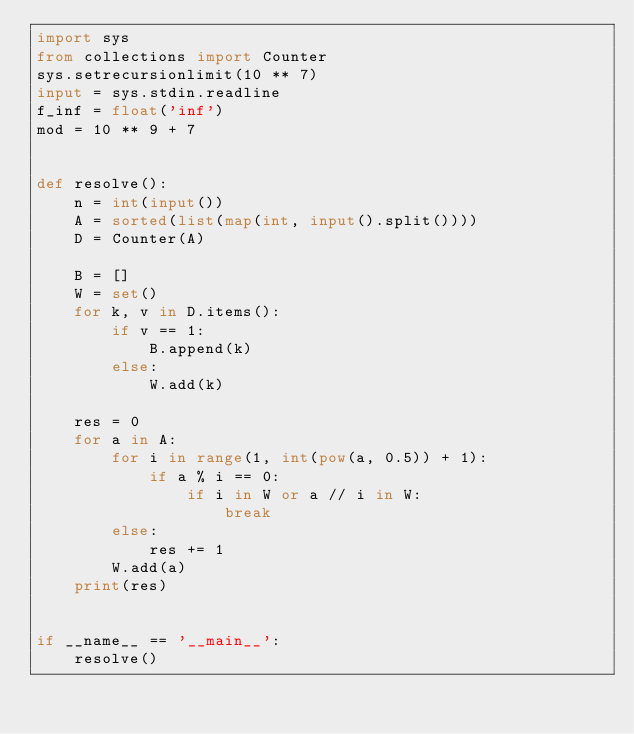<code> <loc_0><loc_0><loc_500><loc_500><_Python_>import sys
from collections import Counter
sys.setrecursionlimit(10 ** 7)
input = sys.stdin.readline
f_inf = float('inf')
mod = 10 ** 9 + 7


def resolve():
    n = int(input())
    A = sorted(list(map(int, input().split())))
    D = Counter(A)

    B = []
    W = set()
    for k, v in D.items():
        if v == 1:
            B.append(k)
        else:
            W.add(k)

    res = 0
    for a in A:
        for i in range(1, int(pow(a, 0.5)) + 1):
            if a % i == 0:
                if i in W or a // i in W:
                    break
        else:
            res += 1
        W.add(a)
    print(res)


if __name__ == '__main__':
    resolve()
</code> 